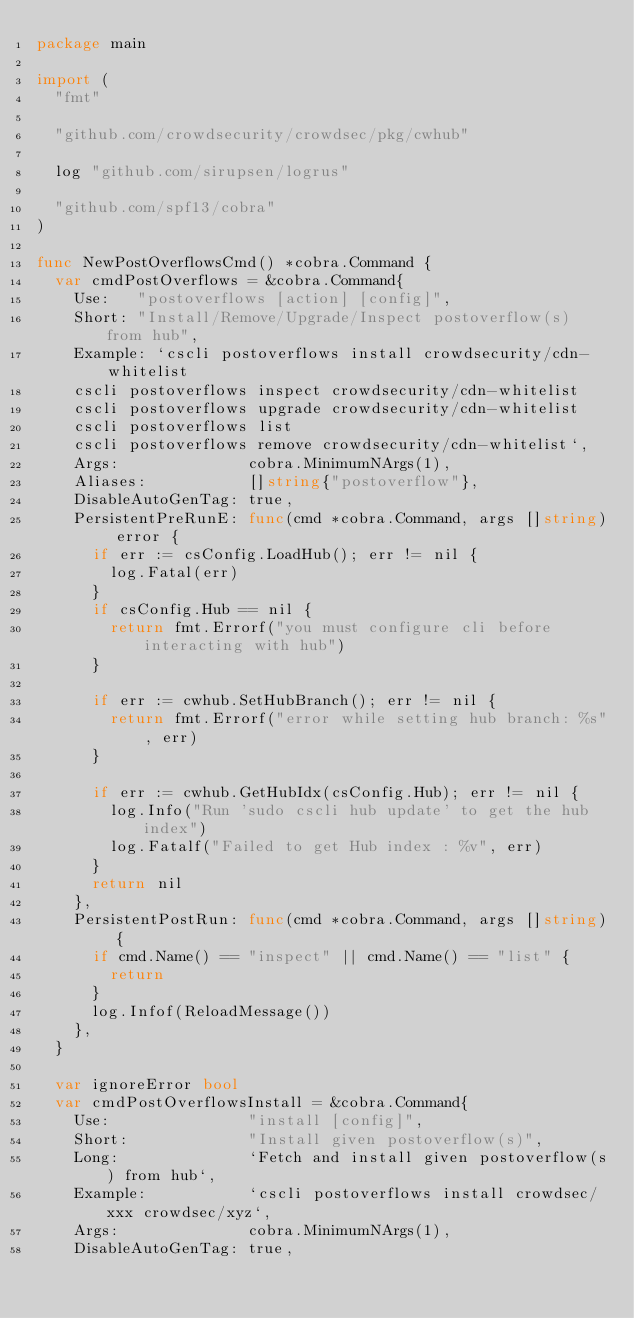Convert code to text. <code><loc_0><loc_0><loc_500><loc_500><_Go_>package main

import (
	"fmt"

	"github.com/crowdsecurity/crowdsec/pkg/cwhub"

	log "github.com/sirupsen/logrus"

	"github.com/spf13/cobra"
)

func NewPostOverflowsCmd() *cobra.Command {
	var cmdPostOverflows = &cobra.Command{
		Use:   "postoverflows [action] [config]",
		Short: "Install/Remove/Upgrade/Inspect postoverflow(s) from hub",
		Example: `cscli postoverflows install crowdsecurity/cdn-whitelist
		cscli postoverflows inspect crowdsecurity/cdn-whitelist
		cscli postoverflows upgrade crowdsecurity/cdn-whitelist
		cscli postoverflows list
		cscli postoverflows remove crowdsecurity/cdn-whitelist`,
		Args:              cobra.MinimumNArgs(1),
		Aliases:           []string{"postoverflow"},
		DisableAutoGenTag: true,
		PersistentPreRunE: func(cmd *cobra.Command, args []string) error {
			if err := csConfig.LoadHub(); err != nil {
				log.Fatal(err)
			}
			if csConfig.Hub == nil {
				return fmt.Errorf("you must configure cli before interacting with hub")
			}

			if err := cwhub.SetHubBranch(); err != nil {
				return fmt.Errorf("error while setting hub branch: %s", err)
			}

			if err := cwhub.GetHubIdx(csConfig.Hub); err != nil {
				log.Info("Run 'sudo cscli hub update' to get the hub index")
				log.Fatalf("Failed to get Hub index : %v", err)
			}
			return nil
		},
		PersistentPostRun: func(cmd *cobra.Command, args []string) {
			if cmd.Name() == "inspect" || cmd.Name() == "list" {
				return
			}
			log.Infof(ReloadMessage())
		},
	}

	var ignoreError bool
	var cmdPostOverflowsInstall = &cobra.Command{
		Use:               "install [config]",
		Short:             "Install given postoverflow(s)",
		Long:              `Fetch and install given postoverflow(s) from hub`,
		Example:           `cscli postoverflows install crowdsec/xxx crowdsec/xyz`,
		Args:              cobra.MinimumNArgs(1),
		DisableAutoGenTag: true,</code> 